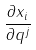<formula> <loc_0><loc_0><loc_500><loc_500>\frac { \partial x _ { i } } { \partial q ^ { j } }</formula> 